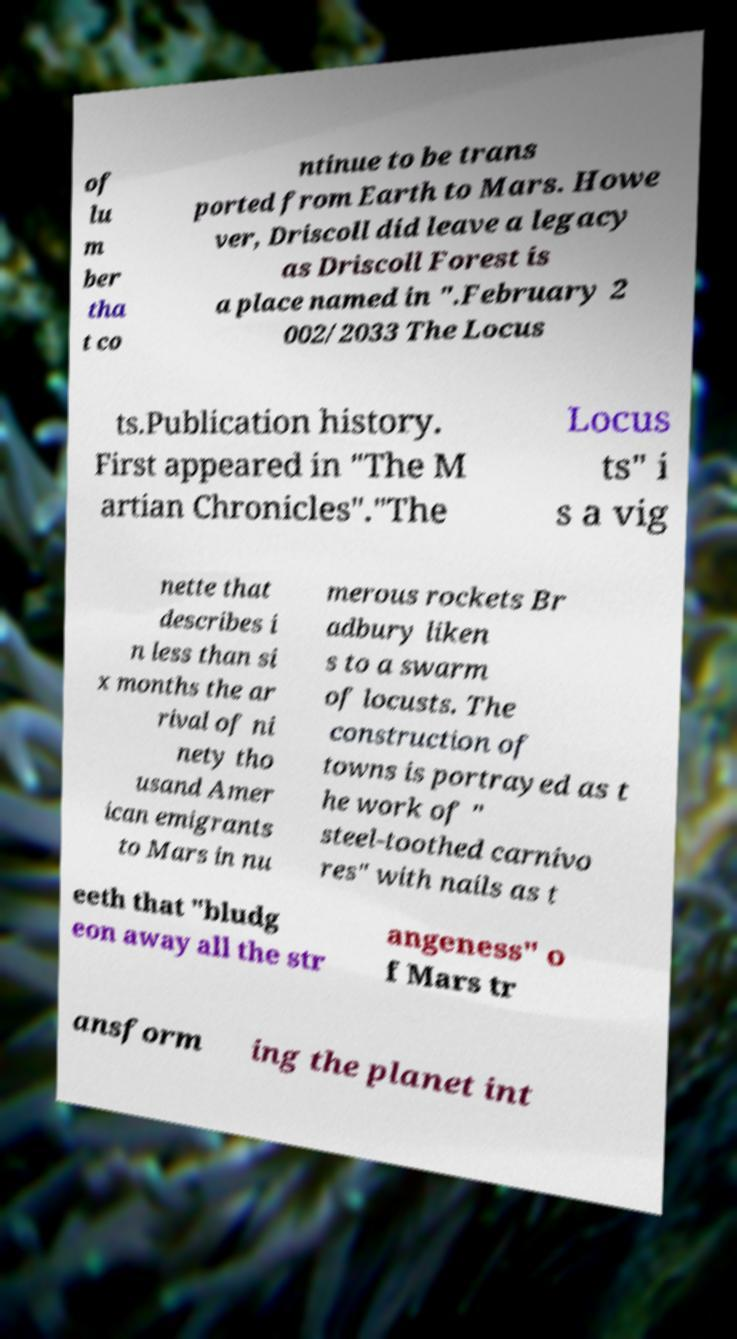There's text embedded in this image that I need extracted. Can you transcribe it verbatim? of lu m ber tha t co ntinue to be trans ported from Earth to Mars. Howe ver, Driscoll did leave a legacy as Driscoll Forest is a place named in ".February 2 002/2033 The Locus ts.Publication history. First appeared in "The M artian Chronicles"."The Locus ts" i s a vig nette that describes i n less than si x months the ar rival of ni nety tho usand Amer ican emigrants to Mars in nu merous rockets Br adbury liken s to a swarm of locusts. The construction of towns is portrayed as t he work of " steel-toothed carnivo res" with nails as t eeth that "bludg eon away all the str angeness" o f Mars tr ansform ing the planet int 